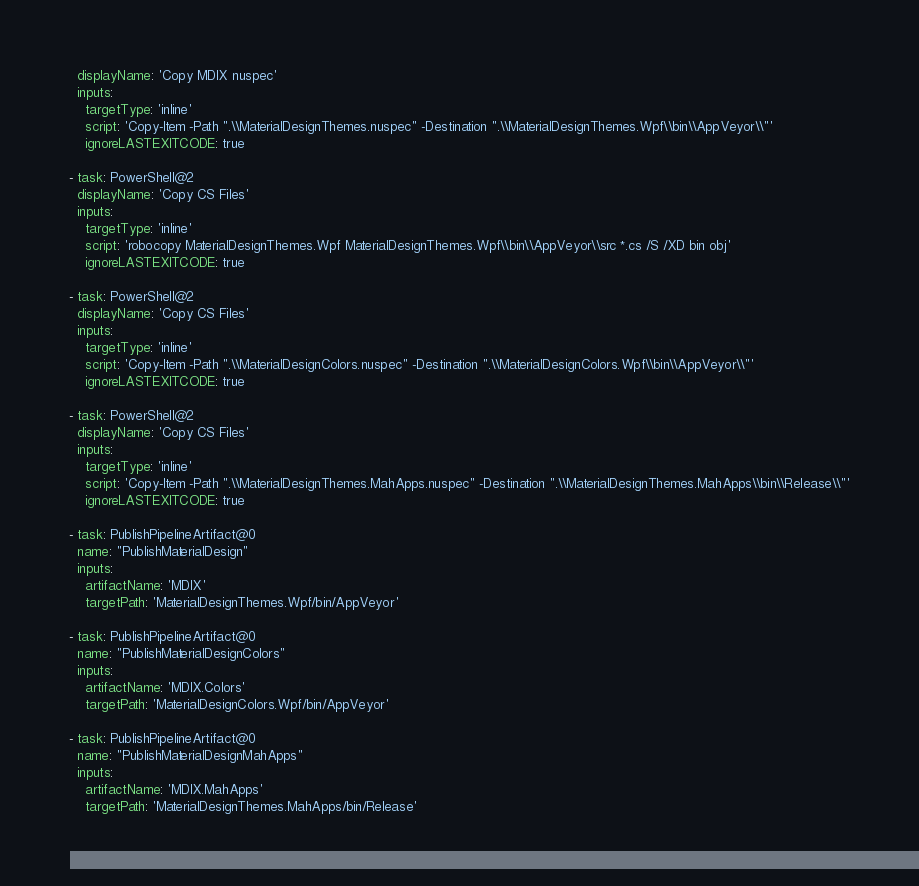Convert code to text. <code><loc_0><loc_0><loc_500><loc_500><_YAML_>  displayName: 'Copy MDIX nuspec'
  inputs:
    targetType: 'inline'
    script: 'Copy-Item -Path ".\\MaterialDesignThemes.nuspec" -Destination ".\\MaterialDesignThemes.Wpf\\bin\\AppVeyor\\"'
    ignoreLASTEXITCODE: true

- task: PowerShell@2
  displayName: 'Copy CS Files'
  inputs:
    targetType: 'inline'
    script: 'robocopy MaterialDesignThemes.Wpf MaterialDesignThemes.Wpf\\bin\\AppVeyor\\src *.cs /S /XD bin obj'
    ignoreLASTEXITCODE: true

- task: PowerShell@2
  displayName: 'Copy CS Files'
  inputs:
    targetType: 'inline'
    script: 'Copy-Item -Path ".\\MaterialDesignColors.nuspec" -Destination ".\\MaterialDesignColors.Wpf\\bin\\AppVeyor\\"'
    ignoreLASTEXITCODE: true

- task: PowerShell@2
  displayName: 'Copy CS Files'
  inputs:
    targetType: 'inline'
    script: 'Copy-Item -Path ".\\MaterialDesignThemes.MahApps.nuspec" -Destination ".\\MaterialDesignThemes.MahApps\\bin\\Release\\"'
    ignoreLASTEXITCODE: true

- task: PublishPipelineArtifact@0
  name: "PublishMaterialDesign"
  inputs:
    artifactName: 'MDIX'
    targetPath: 'MaterialDesignThemes.Wpf/bin/AppVeyor'

- task: PublishPipelineArtifact@0
  name: "PublishMaterialDesignColors"
  inputs:
    artifactName: 'MDIX.Colors'
    targetPath: 'MaterialDesignColors.Wpf/bin/AppVeyor'

- task: PublishPipelineArtifact@0
  name: "PublishMaterialDesignMahApps"
  inputs:
    artifactName: 'MDIX.MahApps'
    targetPath: 'MaterialDesignThemes.MahApps/bin/Release'</code> 